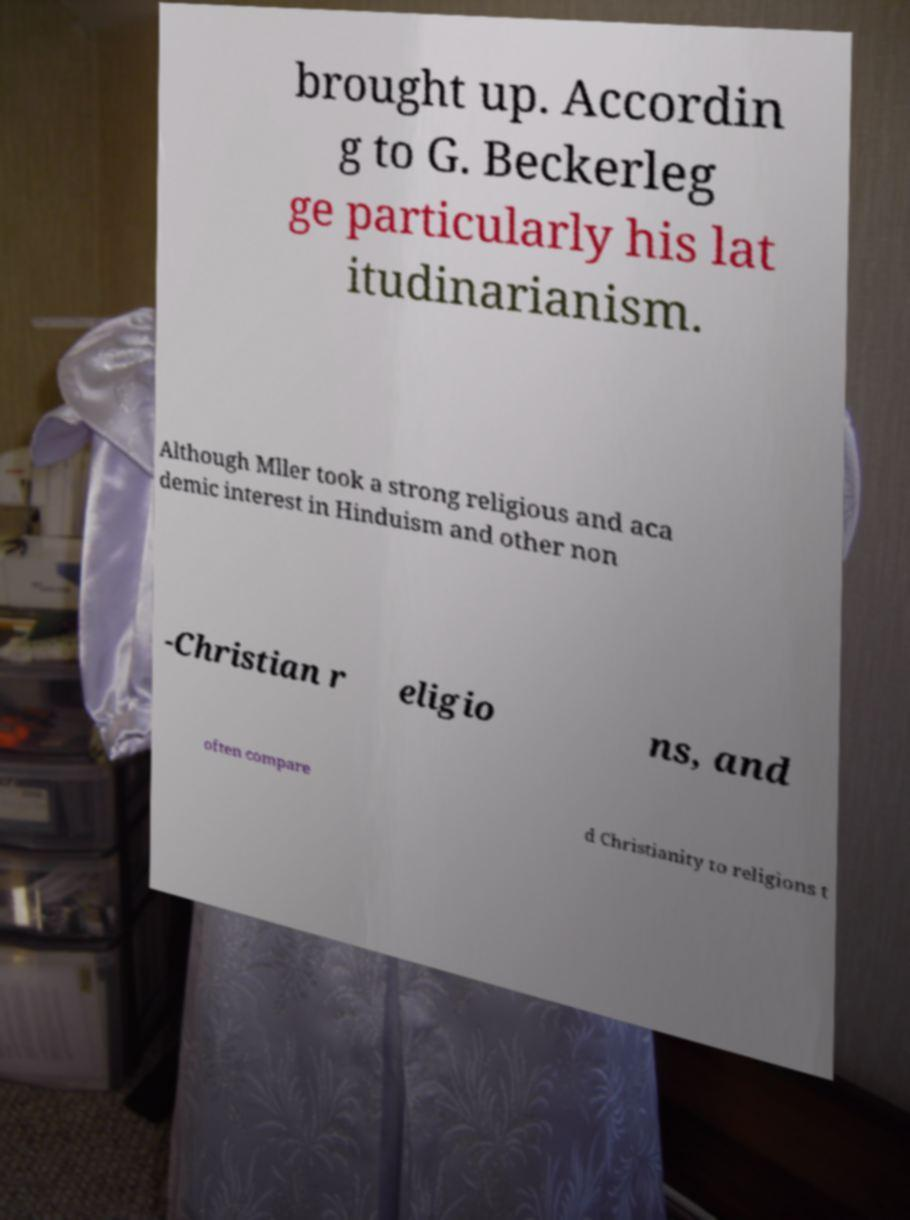There's text embedded in this image that I need extracted. Can you transcribe it verbatim? brought up. Accordin g to G. Beckerleg ge particularly his lat itudinarianism. Although Mller took a strong religious and aca demic interest in Hinduism and other non -Christian r eligio ns, and often compare d Christianity to religions t 